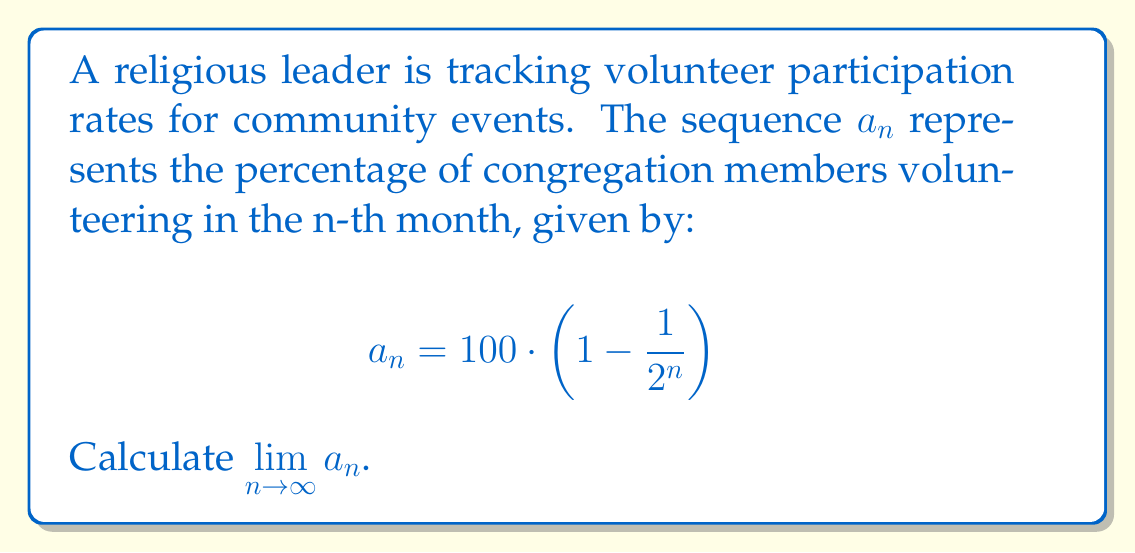Can you answer this question? To find the limit of this sequence as n approaches infinity, we'll follow these steps:

1) First, let's examine the general term of the sequence:
   $$a_n = 100 \cdot \left(1 - \frac{1}{2^n}\right)$$

2) As $n$ increases, $\frac{1}{2^n}$ approaches 0. We can see this because:
   $$\lim_{n \to \infty} \frac{1}{2^n} = 0$$

3) Therefore, as $n$ approaches infinity, the term inside the parentheses approaches 1:
   $$\lim_{n \to \infty} \left(1 - \frac{1}{2^n}\right) = 1 - 0 = 1$$

4) Now, we can apply the limit to the entire expression:
   $$\lim_{n \to \infty} a_n = \lim_{n \to \infty} 100 \cdot \left(1 - \frac{1}{2^n}\right)$$

5) Using the limit laws, we can distribute the limit:
   $$= 100 \cdot \lim_{n \to \infty} \left(1 - \frac{1}{2^n}\right)$$

6) From step 3, we know that this limit equals 1:
   $$= 100 \cdot 1 = 100$$

Therefore, the limit of the sequence as n approaches infinity is 100.
Answer: $\lim_{n \to \infty} a_n = 100$ 